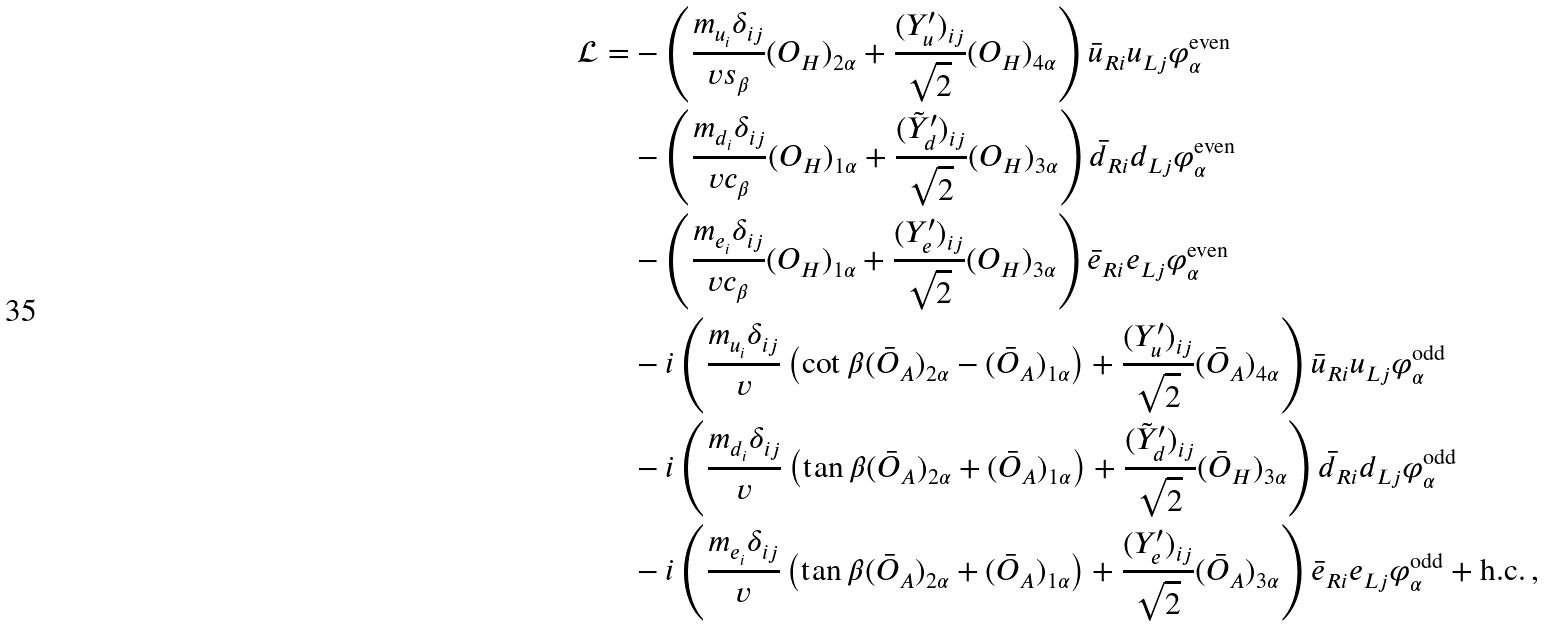Convert formula to latex. <formula><loc_0><loc_0><loc_500><loc_500>\mathcal { L } = & - \left ( \frac { m _ { u _ { i } } \delta _ { i j } } { v s _ { \beta } } ( O _ { H } ) _ { 2 \alpha } + \frac { ( Y _ { u } ^ { \prime } ) _ { i j } } { \sqrt { 2 } } ( O _ { H } ) _ { 4 \alpha } \right ) \bar { u } _ { R i } u _ { L j } \varphi ^ { \text {even} } _ { \alpha } \\ & - \left ( \frac { m _ { d _ { i } } \delta _ { i j } } { v c _ { \beta } } ( O _ { H } ) _ { 1 \alpha } + \frac { ( \tilde { Y } _ { d } ^ { \prime } ) _ { i j } } { \sqrt { 2 } } ( O _ { H } ) _ { 3 \alpha } \right ) \bar { d } _ { R i } d _ { L j } \varphi ^ { \text {even} } _ { \alpha } \\ & - \left ( \frac { m _ { e _ { i } } \delta _ { i j } } { v c _ { \beta } } ( O _ { H } ) _ { 1 \alpha } + \frac { ( Y _ { e } ^ { \prime } ) _ { i j } } { \sqrt { 2 } } ( O _ { H } ) _ { 3 \alpha } \right ) \bar { e } _ { R i } e _ { L j } \varphi ^ { \text {even} } _ { \alpha } \\ & - i \left ( \frac { m _ { u _ { i } } \delta _ { i j } } { v } \left ( \cot \beta ( \bar { O } _ { A } ) _ { 2 \alpha } - ( \bar { O } _ { A } ) _ { 1 \alpha } \right ) + \frac { ( Y _ { u } ^ { \prime } ) _ { i j } } { \sqrt { 2 } } ( \bar { O } _ { A } ) _ { 4 \alpha } \right ) \bar { u } _ { R i } u _ { L j } \varphi ^ { \text {odd} } _ { \alpha } \\ & - i \left ( \frac { m _ { d _ { i } } \delta _ { i j } } { v } \left ( \tan \beta ( \bar { O } _ { A } ) _ { 2 \alpha } + ( \bar { O } _ { A } ) _ { 1 \alpha } \right ) + \frac { ( \tilde { Y } _ { d } ^ { \prime } ) _ { i j } } { \sqrt { 2 } } ( \bar { O } _ { H } ) _ { 3 \alpha } \right ) \bar { d } _ { R i } d _ { L j } \varphi ^ { \text {odd} } _ { \alpha } \\ & - i \left ( \frac { m _ { e _ { i } } \delta _ { i j } } { v } \left ( \tan \beta ( \bar { O } _ { A } ) _ { 2 \alpha } + ( \bar { O } _ { A } ) _ { 1 \alpha } \right ) + \frac { ( Y _ { e } ^ { \prime } ) _ { i j } } { \sqrt { 2 } } ( \bar { O } _ { A } ) _ { 3 \alpha } \right ) \bar { e } _ { R i } e _ { L j } \varphi ^ { \text {odd} } _ { \alpha } + \text {h.c.} \, ,</formula> 